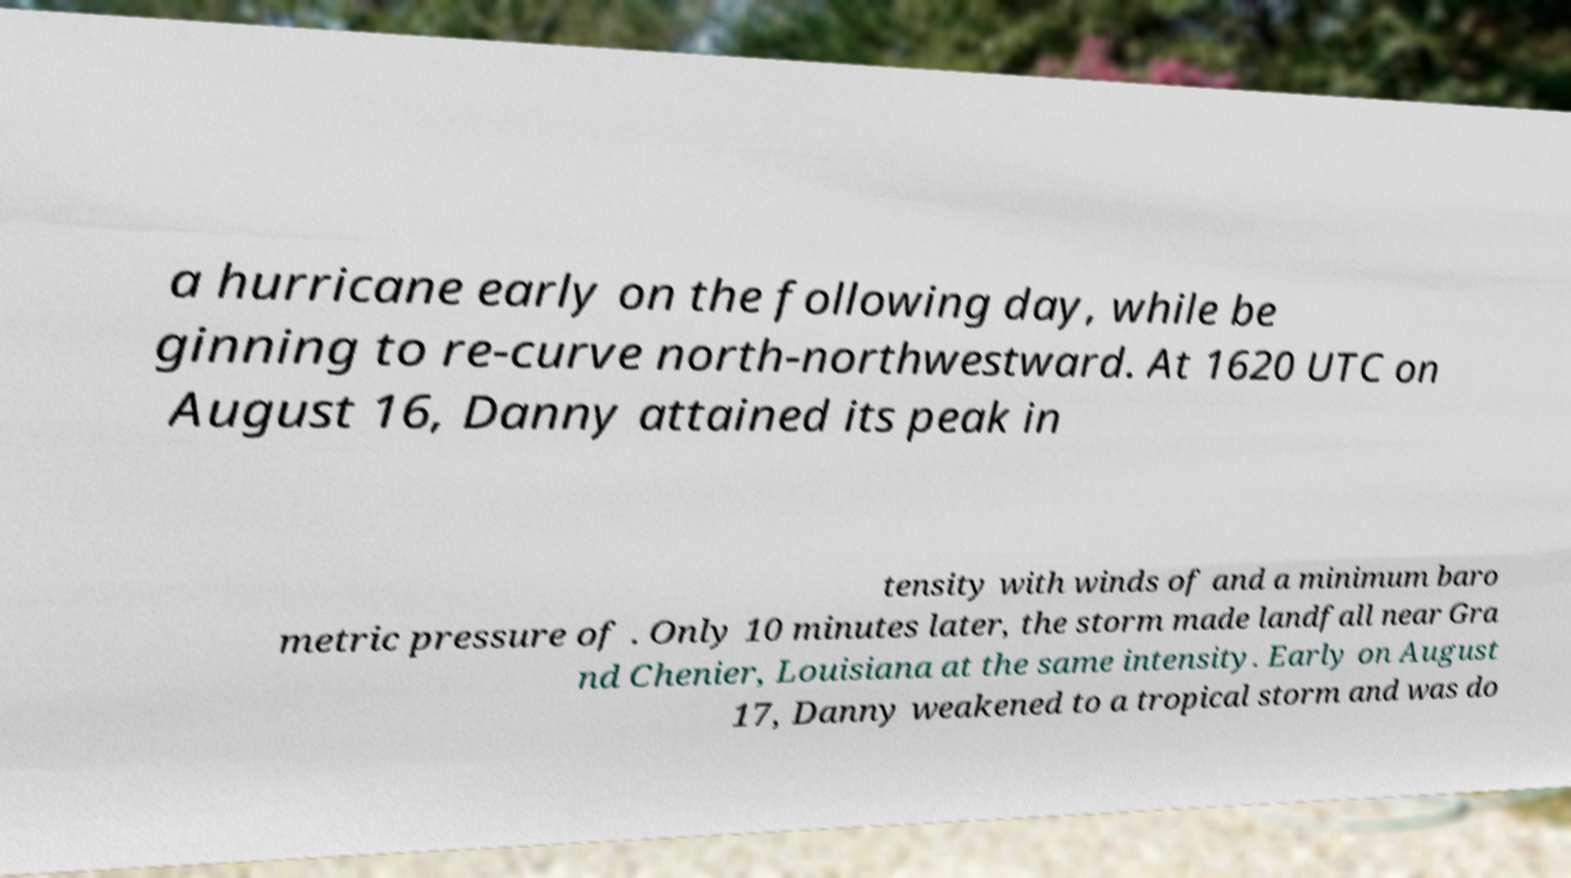There's text embedded in this image that I need extracted. Can you transcribe it verbatim? a hurricane early on the following day, while be ginning to re-curve north-northwestward. At 1620 UTC on August 16, Danny attained its peak in tensity with winds of and a minimum baro metric pressure of . Only 10 minutes later, the storm made landfall near Gra nd Chenier, Louisiana at the same intensity. Early on August 17, Danny weakened to a tropical storm and was do 